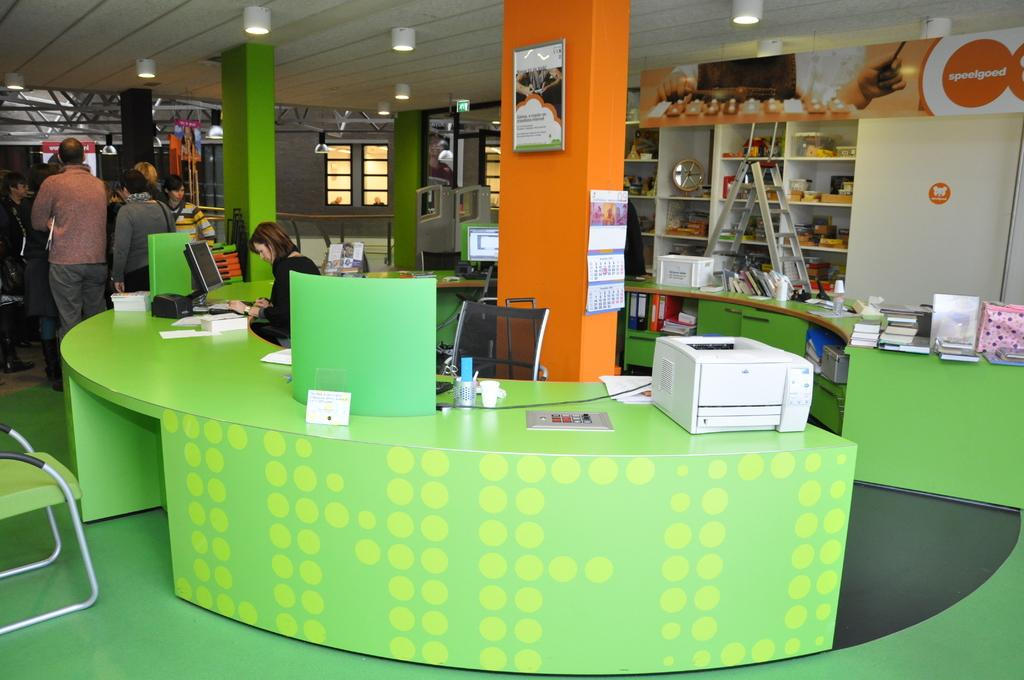How many people can be seen in the image? There are people in the image, but the exact number cannot be determined from the provided facts. What type of furniture is present in the image? There is a table and chairs in the image. What electronic devices can be seen in the image? A laptop and a printer are visible in the image. What type of storage is present in the image? Racks filled with objects are in the image. What architectural features are present in the image? There are pillars in the image. What type of lighting is present in the image? Lights are visible in the image. What type of openings are present in the image? Windows are present in the image. What type of thrill can be seen on the faces of the people in the image? There is no indication of any thrill or emotion on the faces of the people in the image. What type of spoon is used to stir the coffee in the image? There is no coffee or spoon present in the image. 